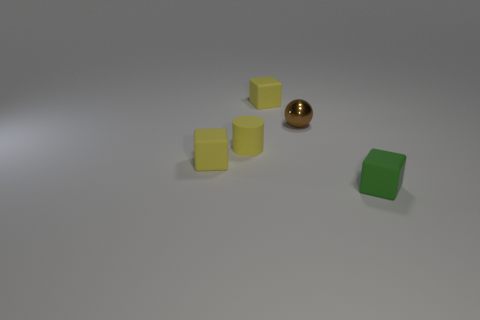Subtract all yellow cubes. How many cubes are left? 1 Add 5 small yellow things. How many objects exist? 10 Subtract all blue balls. How many yellow blocks are left? 2 Subtract 1 cylinders. How many cylinders are left? 0 Subtract all green blocks. How many blocks are left? 2 Subtract all cylinders. How many objects are left? 4 Subtract all big balls. Subtract all small brown things. How many objects are left? 4 Add 2 blocks. How many blocks are left? 5 Add 1 tiny matte things. How many tiny matte things exist? 5 Subtract 0 gray spheres. How many objects are left? 5 